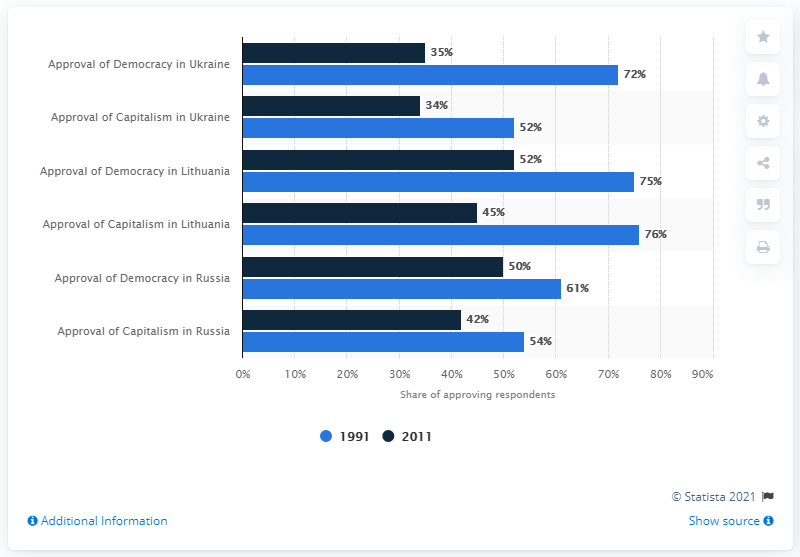Indicate a few pertinent items in this graphic. In 1991, 50% of Russians approved of the change to a multiparty system. 